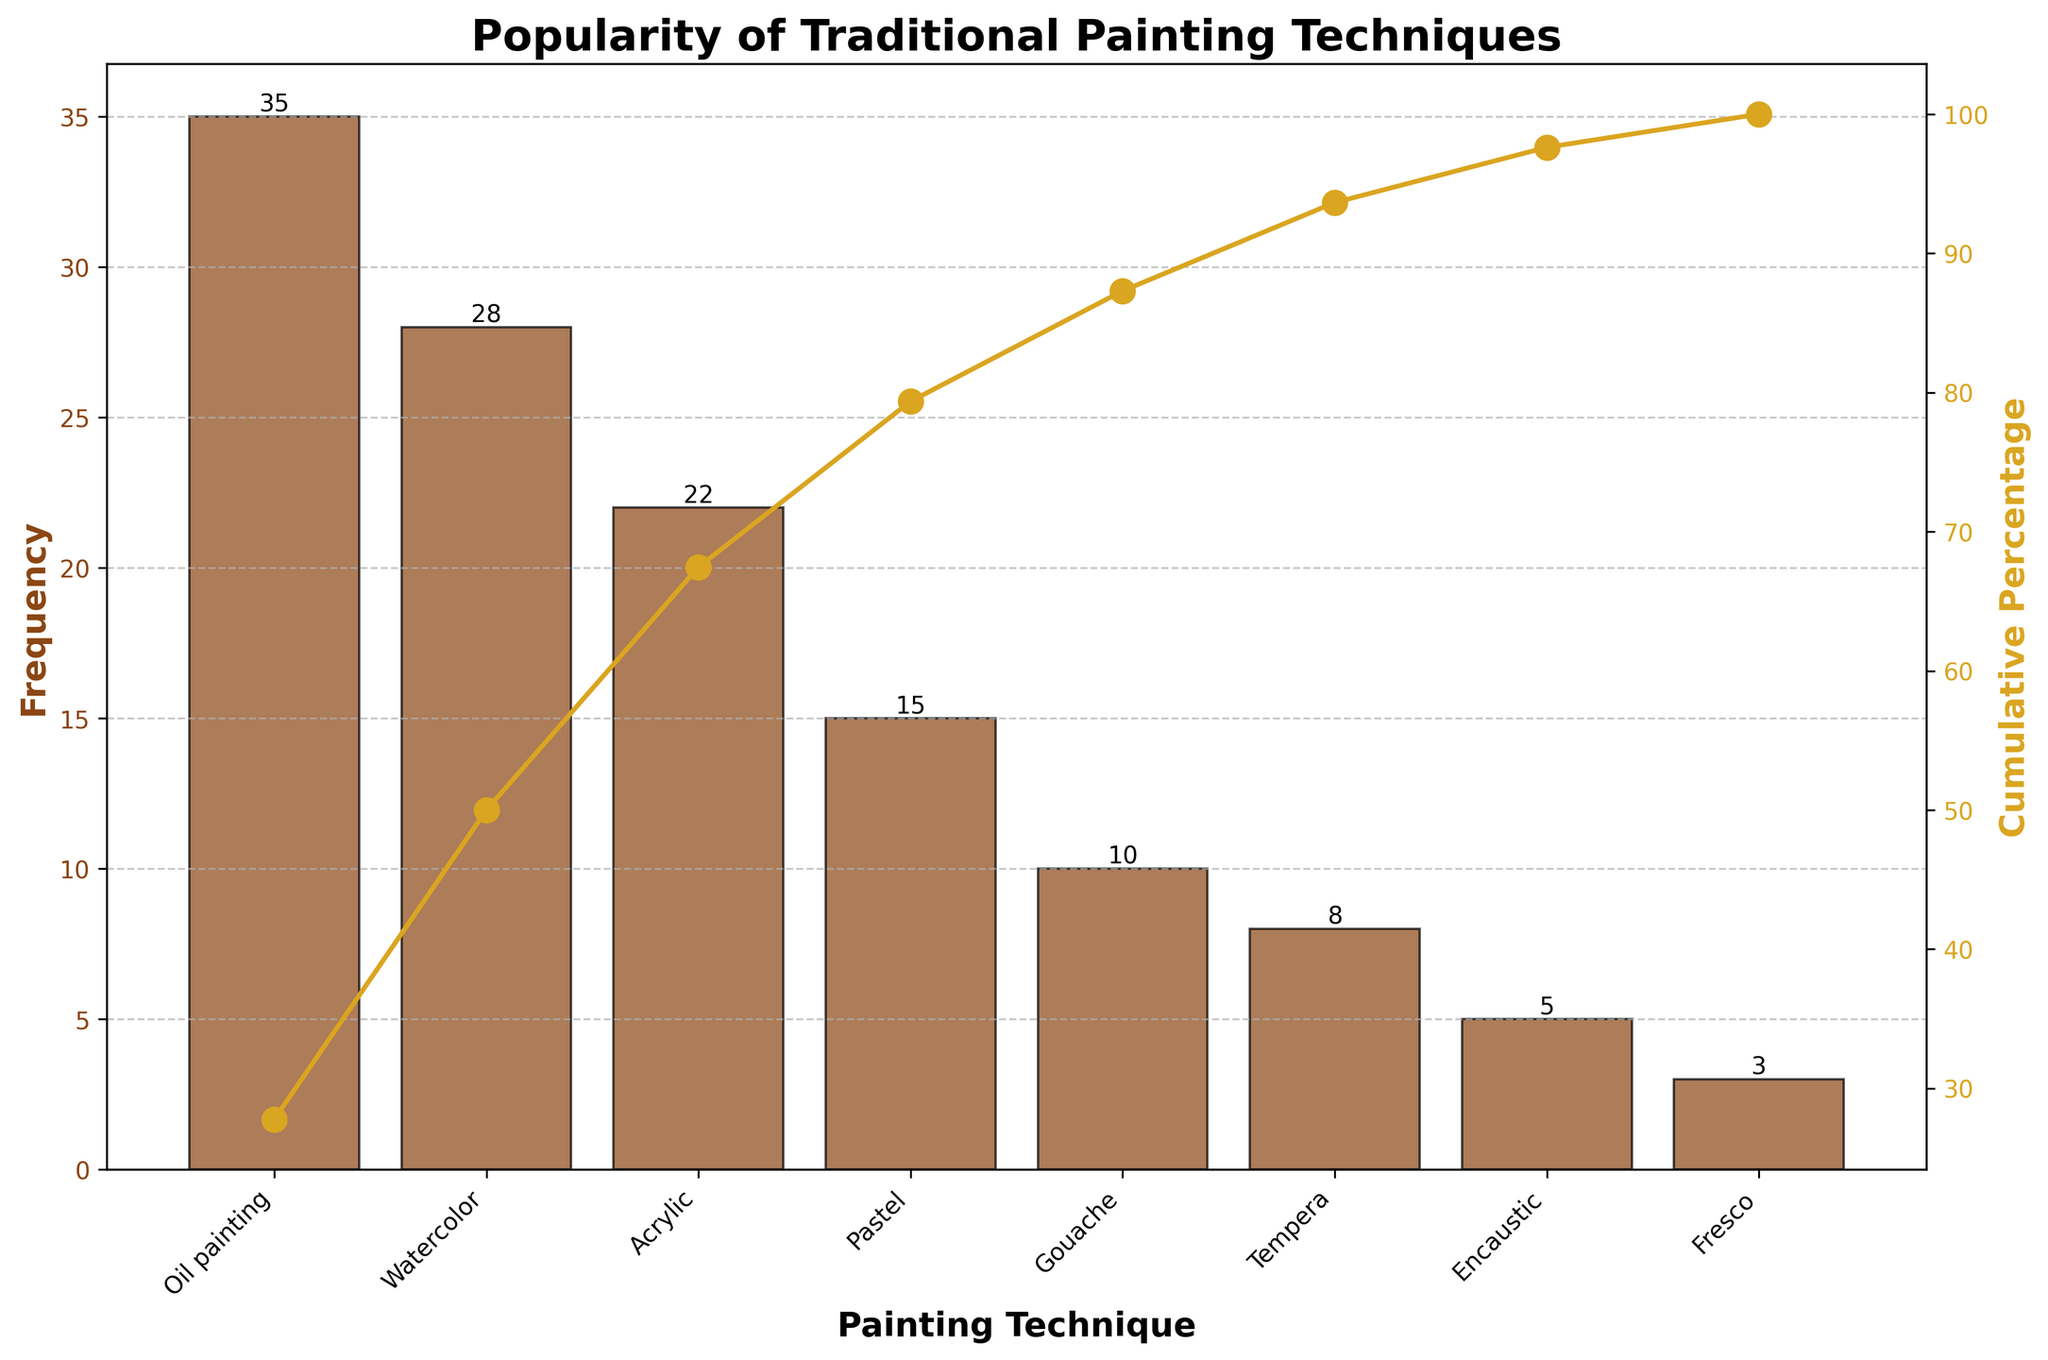What is the title of the figure? The title of a figure is typically located at the top and provides a brief description of what the chart represents. In this case, the title should mention what is being compared or analyzed.
Answer: Popularity of Traditional Painting Techniques Which painting technique is used most frequently? The most frequently used technique would have the highest bar on the chart. Look for the bar with the greatest height.
Answer: Oil painting What is the frequency of the least popular technique? Identify the smallest bar on the chart and check the label or numerical value associated with it to find the frequency of the least popular technique.
Answer: 3 How many painting techniques are shown in the figure? Count the number of bars or labels along the x-axis to determine the total number of painting techniques displayed.
Answer: 8 What is the cumulative percentage for acrylic painting? To find this value, locate the bar for acrylic painting and trace it up to the connected line showing the cumulative percentage.
Answer: 82.69% What percentage of total frequency do oil painting and watercolor together represent? First, identify the frequencies of oil painting and watercolor (35 and 28 respectively). Sum them up to get 63, then divide by the total frequency (126) and multiply by 100 to get the percentage. 63/126 * 100 = 50%.
Answer: 50% Which technique contributes more to the cumulative percentage, gouache or pastel? Compare the height of the bars for gouache and pastel and look at their positions relative to the cumulative percentage. Gouache (10) is less than pastel (15), meaning pastel contributes more to the cumulative percentage.
Answer: Pastel How many techniques have a cumulative percentage below 70%? Trace the cumulative percentage line and count the number of techniques that fall below the 70% marker.
Answer: 3 What is the difference in frequency between the most and least popular techniques? Subtract the frequency of the least popular technique (3) from the frequency of the most popular technique (35). 35 - 3 = 32.
Answer: 32 How much does tempera contribute to the overall frequency? Identify the frequency of tempera (8) and divide by the total frequency (126). Multiply by 100 to convert to percentage. (8/126) * 100 = 6.35%.
Answer: 6.35% 